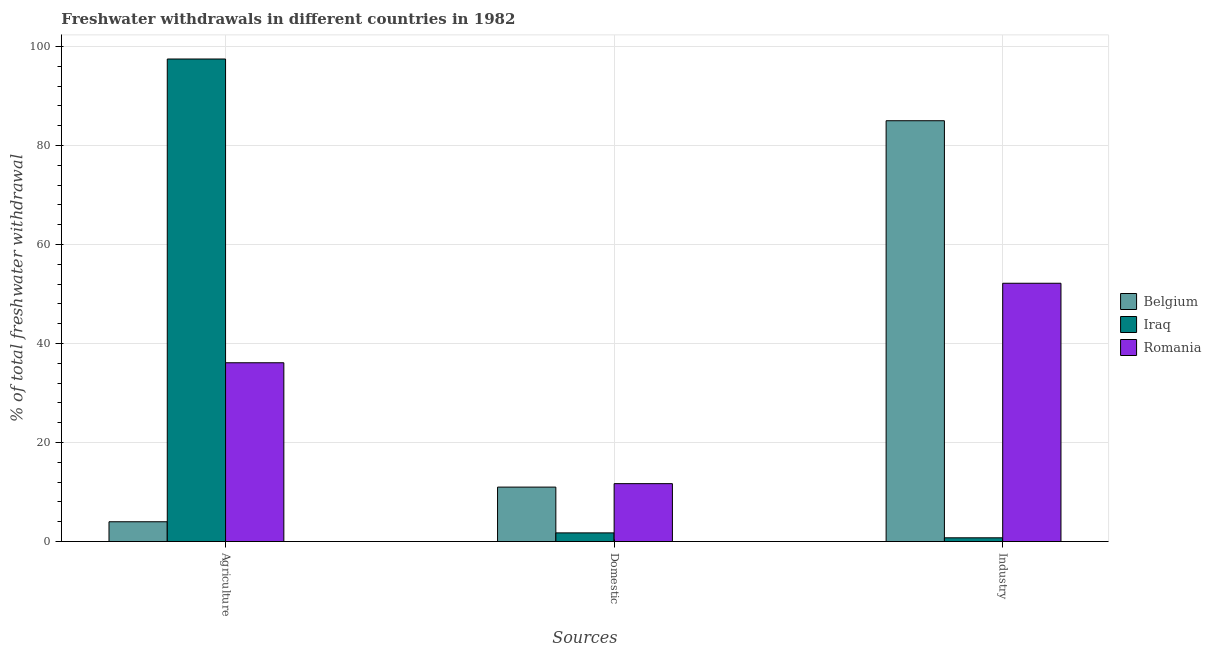How many different coloured bars are there?
Ensure brevity in your answer.  3. Are the number of bars per tick equal to the number of legend labels?
Provide a succinct answer. Yes. How many bars are there on the 3rd tick from the left?
Offer a terse response. 3. How many bars are there on the 2nd tick from the right?
Provide a short and direct response. 3. What is the label of the 2nd group of bars from the left?
Your response must be concise. Domestic. What is the percentage of freshwater withdrawal for industry in Romania?
Your response must be concise. 52.18. Across all countries, what is the maximum percentage of freshwater withdrawal for industry?
Your response must be concise. 85.01. Across all countries, what is the minimum percentage of freshwater withdrawal for industry?
Your response must be concise. 0.76. In which country was the percentage of freshwater withdrawal for domestic purposes maximum?
Your answer should be compact. Romania. What is the total percentage of freshwater withdrawal for agriculture in the graph?
Give a very brief answer. 137.6. What is the difference between the percentage of freshwater withdrawal for industry in Iraq and that in Belgium?
Offer a very short reply. -84.25. What is the difference between the percentage of freshwater withdrawal for industry in Belgium and the percentage of freshwater withdrawal for agriculture in Romania?
Your answer should be very brief. 48.89. What is the average percentage of freshwater withdrawal for industry per country?
Ensure brevity in your answer.  45.98. What is the difference between the percentage of freshwater withdrawal for industry and percentage of freshwater withdrawal for domestic purposes in Iraq?
Your answer should be very brief. -0.99. In how many countries, is the percentage of freshwater withdrawal for industry greater than 56 %?
Provide a succinct answer. 1. What is the ratio of the percentage of freshwater withdrawal for industry in Belgium to that in Iraq?
Your answer should be very brief. 111.88. Is the percentage of freshwater withdrawal for domestic purposes in Belgium less than that in Iraq?
Ensure brevity in your answer.  No. Is the difference between the percentage of freshwater withdrawal for domestic purposes in Romania and Belgium greater than the difference between the percentage of freshwater withdrawal for agriculture in Romania and Belgium?
Ensure brevity in your answer.  No. What is the difference between the highest and the second highest percentage of freshwater withdrawal for domestic purposes?
Your answer should be compact. 0.7. What is the difference between the highest and the lowest percentage of freshwater withdrawal for domestic purposes?
Keep it short and to the point. 9.95. In how many countries, is the percentage of freshwater withdrawal for industry greater than the average percentage of freshwater withdrawal for industry taken over all countries?
Your answer should be very brief. 2. Is the sum of the percentage of freshwater withdrawal for domestic purposes in Iraq and Romania greater than the maximum percentage of freshwater withdrawal for agriculture across all countries?
Your response must be concise. No. What does the 3rd bar from the left in Agriculture represents?
Offer a very short reply. Romania. What does the 1st bar from the right in Domestic represents?
Your answer should be very brief. Romania. How many bars are there?
Ensure brevity in your answer.  9. What is the difference between two consecutive major ticks on the Y-axis?
Ensure brevity in your answer.  20. Are the values on the major ticks of Y-axis written in scientific E-notation?
Make the answer very short. No. What is the title of the graph?
Make the answer very short. Freshwater withdrawals in different countries in 1982. What is the label or title of the X-axis?
Ensure brevity in your answer.  Sources. What is the label or title of the Y-axis?
Your answer should be compact. % of total freshwater withdrawal. What is the % of total freshwater withdrawal of Iraq in Agriculture?
Keep it short and to the point. 97.48. What is the % of total freshwater withdrawal in Romania in Agriculture?
Provide a succinct answer. 36.12. What is the % of total freshwater withdrawal of Belgium in Domestic?
Provide a short and direct response. 11. What is the % of total freshwater withdrawal of Iraq in Domestic?
Give a very brief answer. 1.75. What is the % of total freshwater withdrawal of Belgium in Industry?
Give a very brief answer. 85.01. What is the % of total freshwater withdrawal of Iraq in Industry?
Keep it short and to the point. 0.76. What is the % of total freshwater withdrawal in Romania in Industry?
Your answer should be very brief. 52.18. Across all Sources, what is the maximum % of total freshwater withdrawal in Belgium?
Keep it short and to the point. 85.01. Across all Sources, what is the maximum % of total freshwater withdrawal of Iraq?
Your answer should be very brief. 97.48. Across all Sources, what is the maximum % of total freshwater withdrawal in Romania?
Offer a terse response. 52.18. Across all Sources, what is the minimum % of total freshwater withdrawal of Iraq?
Provide a succinct answer. 0.76. What is the total % of total freshwater withdrawal in Belgium in the graph?
Keep it short and to the point. 100.01. What is the total % of total freshwater withdrawal in Iraq in the graph?
Provide a short and direct response. 99.99. What is the total % of total freshwater withdrawal of Romania in the graph?
Ensure brevity in your answer.  100. What is the difference between the % of total freshwater withdrawal in Iraq in Agriculture and that in Domestic?
Your answer should be compact. 95.73. What is the difference between the % of total freshwater withdrawal in Romania in Agriculture and that in Domestic?
Give a very brief answer. 24.42. What is the difference between the % of total freshwater withdrawal of Belgium in Agriculture and that in Industry?
Offer a terse response. -81.01. What is the difference between the % of total freshwater withdrawal in Iraq in Agriculture and that in Industry?
Offer a very short reply. 96.72. What is the difference between the % of total freshwater withdrawal in Romania in Agriculture and that in Industry?
Ensure brevity in your answer.  -16.06. What is the difference between the % of total freshwater withdrawal of Belgium in Domestic and that in Industry?
Provide a succinct answer. -74.01. What is the difference between the % of total freshwater withdrawal of Romania in Domestic and that in Industry?
Provide a short and direct response. -40.48. What is the difference between the % of total freshwater withdrawal of Belgium in Agriculture and the % of total freshwater withdrawal of Iraq in Domestic?
Your answer should be very brief. 2.25. What is the difference between the % of total freshwater withdrawal in Iraq in Agriculture and the % of total freshwater withdrawal in Romania in Domestic?
Provide a short and direct response. 85.78. What is the difference between the % of total freshwater withdrawal of Belgium in Agriculture and the % of total freshwater withdrawal of Iraq in Industry?
Offer a very short reply. 3.24. What is the difference between the % of total freshwater withdrawal in Belgium in Agriculture and the % of total freshwater withdrawal in Romania in Industry?
Ensure brevity in your answer.  -48.18. What is the difference between the % of total freshwater withdrawal in Iraq in Agriculture and the % of total freshwater withdrawal in Romania in Industry?
Provide a short and direct response. 45.3. What is the difference between the % of total freshwater withdrawal of Belgium in Domestic and the % of total freshwater withdrawal of Iraq in Industry?
Your response must be concise. 10.24. What is the difference between the % of total freshwater withdrawal in Belgium in Domestic and the % of total freshwater withdrawal in Romania in Industry?
Provide a short and direct response. -41.18. What is the difference between the % of total freshwater withdrawal of Iraq in Domestic and the % of total freshwater withdrawal of Romania in Industry?
Your response must be concise. -50.43. What is the average % of total freshwater withdrawal of Belgium per Sources?
Provide a short and direct response. 33.34. What is the average % of total freshwater withdrawal of Iraq per Sources?
Offer a very short reply. 33.33. What is the average % of total freshwater withdrawal of Romania per Sources?
Ensure brevity in your answer.  33.33. What is the difference between the % of total freshwater withdrawal in Belgium and % of total freshwater withdrawal in Iraq in Agriculture?
Keep it short and to the point. -93.48. What is the difference between the % of total freshwater withdrawal of Belgium and % of total freshwater withdrawal of Romania in Agriculture?
Offer a very short reply. -32.12. What is the difference between the % of total freshwater withdrawal of Iraq and % of total freshwater withdrawal of Romania in Agriculture?
Ensure brevity in your answer.  61.36. What is the difference between the % of total freshwater withdrawal in Belgium and % of total freshwater withdrawal in Iraq in Domestic?
Offer a terse response. 9.25. What is the difference between the % of total freshwater withdrawal in Iraq and % of total freshwater withdrawal in Romania in Domestic?
Keep it short and to the point. -9.95. What is the difference between the % of total freshwater withdrawal in Belgium and % of total freshwater withdrawal in Iraq in Industry?
Your answer should be compact. 84.25. What is the difference between the % of total freshwater withdrawal of Belgium and % of total freshwater withdrawal of Romania in Industry?
Ensure brevity in your answer.  32.83. What is the difference between the % of total freshwater withdrawal in Iraq and % of total freshwater withdrawal in Romania in Industry?
Ensure brevity in your answer.  -51.42. What is the ratio of the % of total freshwater withdrawal in Belgium in Agriculture to that in Domestic?
Offer a terse response. 0.36. What is the ratio of the % of total freshwater withdrawal in Iraq in Agriculture to that in Domestic?
Offer a very short reply. 55.64. What is the ratio of the % of total freshwater withdrawal in Romania in Agriculture to that in Domestic?
Your answer should be very brief. 3.09. What is the ratio of the % of total freshwater withdrawal of Belgium in Agriculture to that in Industry?
Make the answer very short. 0.05. What is the ratio of the % of total freshwater withdrawal of Iraq in Agriculture to that in Industry?
Your answer should be compact. 128.3. What is the ratio of the % of total freshwater withdrawal of Romania in Agriculture to that in Industry?
Provide a short and direct response. 0.69. What is the ratio of the % of total freshwater withdrawal of Belgium in Domestic to that in Industry?
Keep it short and to the point. 0.13. What is the ratio of the % of total freshwater withdrawal in Iraq in Domestic to that in Industry?
Provide a short and direct response. 2.31. What is the ratio of the % of total freshwater withdrawal in Romania in Domestic to that in Industry?
Offer a terse response. 0.22. What is the difference between the highest and the second highest % of total freshwater withdrawal of Belgium?
Your answer should be compact. 74.01. What is the difference between the highest and the second highest % of total freshwater withdrawal of Iraq?
Your answer should be compact. 95.73. What is the difference between the highest and the second highest % of total freshwater withdrawal of Romania?
Provide a succinct answer. 16.06. What is the difference between the highest and the lowest % of total freshwater withdrawal in Belgium?
Your answer should be compact. 81.01. What is the difference between the highest and the lowest % of total freshwater withdrawal of Iraq?
Offer a very short reply. 96.72. What is the difference between the highest and the lowest % of total freshwater withdrawal of Romania?
Provide a succinct answer. 40.48. 